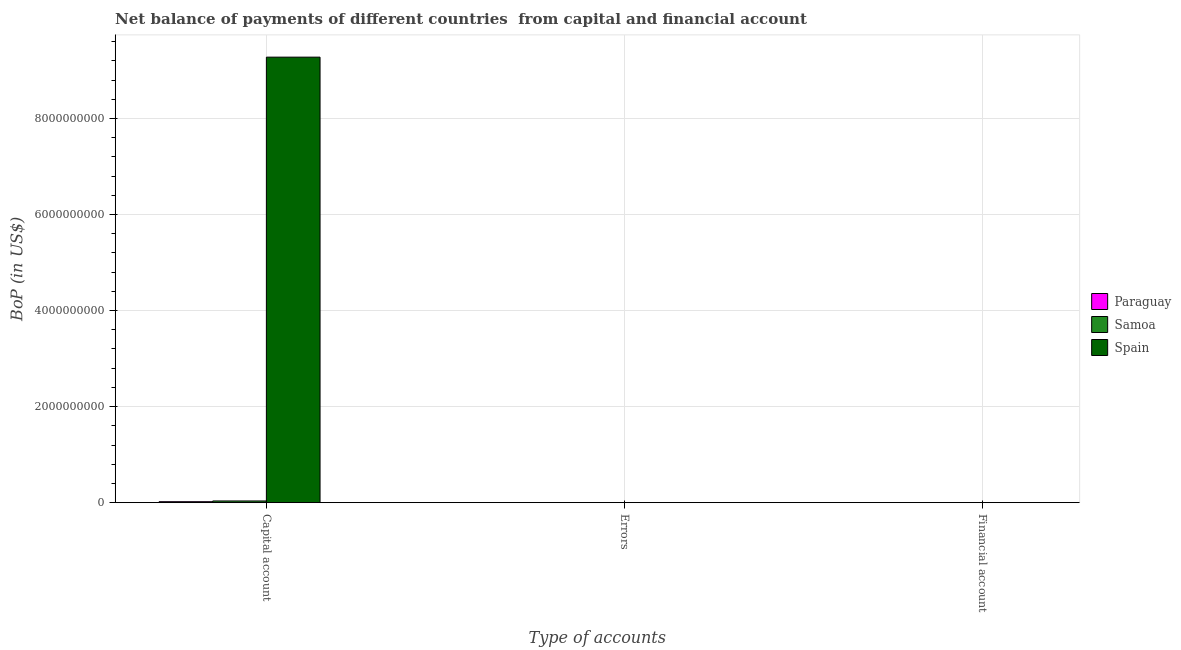Are the number of bars on each tick of the X-axis equal?
Ensure brevity in your answer.  No. What is the label of the 1st group of bars from the left?
Your answer should be compact. Capital account. What is the amount of errors in Samoa?
Provide a short and direct response. 0. Across all countries, what is the maximum amount of net capital account?
Your response must be concise. 9.28e+09. In which country was the amount of net capital account maximum?
Provide a succinct answer. Spain. What is the difference between the amount of net capital account in Samoa and that in Paraguay?
Make the answer very short. 1.51e+07. What is the ratio of the amount of net capital account in Paraguay to that in Spain?
Your answer should be compact. 0. Is the amount of net capital account in Spain less than that in Samoa?
Give a very brief answer. No. What is the difference between the highest and the second highest amount of net capital account?
Ensure brevity in your answer.  9.24e+09. What is the difference between the highest and the lowest amount of net capital account?
Provide a short and direct response. 9.26e+09. In how many countries, is the amount of net capital account greater than the average amount of net capital account taken over all countries?
Give a very brief answer. 1. Is the sum of the amount of net capital account in Spain and Samoa greater than the maximum amount of errors across all countries?
Your response must be concise. Yes. Is it the case that in every country, the sum of the amount of net capital account and amount of errors is greater than the amount of financial account?
Offer a terse response. Yes. Are all the bars in the graph horizontal?
Your response must be concise. No. Are the values on the major ticks of Y-axis written in scientific E-notation?
Give a very brief answer. No. Does the graph contain any zero values?
Give a very brief answer. Yes. Where does the legend appear in the graph?
Provide a short and direct response. Center right. How many legend labels are there?
Your answer should be very brief. 3. What is the title of the graph?
Offer a terse response. Net balance of payments of different countries  from capital and financial account. What is the label or title of the X-axis?
Your response must be concise. Type of accounts. What is the label or title of the Y-axis?
Your answer should be very brief. BoP (in US$). What is the BoP (in US$) of Paraguay in Capital account?
Your response must be concise. 2.00e+07. What is the BoP (in US$) of Samoa in Capital account?
Provide a succinct answer. 3.51e+07. What is the BoP (in US$) in Spain in Capital account?
Give a very brief answer. 9.28e+09. What is the BoP (in US$) of Samoa in Errors?
Your answer should be very brief. 0. What is the BoP (in US$) in Paraguay in Financial account?
Give a very brief answer. 0. What is the BoP (in US$) of Samoa in Financial account?
Provide a succinct answer. 0. What is the BoP (in US$) of Spain in Financial account?
Make the answer very short. 0. Across all Type of accounts, what is the maximum BoP (in US$) of Paraguay?
Your answer should be compact. 2.00e+07. Across all Type of accounts, what is the maximum BoP (in US$) of Samoa?
Keep it short and to the point. 3.51e+07. Across all Type of accounts, what is the maximum BoP (in US$) of Spain?
Make the answer very short. 9.28e+09. Across all Type of accounts, what is the minimum BoP (in US$) of Samoa?
Your response must be concise. 0. What is the total BoP (in US$) in Paraguay in the graph?
Keep it short and to the point. 2.00e+07. What is the total BoP (in US$) of Samoa in the graph?
Offer a very short reply. 3.51e+07. What is the total BoP (in US$) of Spain in the graph?
Your answer should be compact. 9.28e+09. What is the average BoP (in US$) of Paraguay per Type of accounts?
Ensure brevity in your answer.  6.67e+06. What is the average BoP (in US$) in Samoa per Type of accounts?
Provide a short and direct response. 1.17e+07. What is the average BoP (in US$) in Spain per Type of accounts?
Offer a very short reply. 3.09e+09. What is the difference between the BoP (in US$) in Paraguay and BoP (in US$) in Samoa in Capital account?
Ensure brevity in your answer.  -1.51e+07. What is the difference between the BoP (in US$) in Paraguay and BoP (in US$) in Spain in Capital account?
Offer a terse response. -9.26e+09. What is the difference between the BoP (in US$) of Samoa and BoP (in US$) of Spain in Capital account?
Offer a very short reply. -9.24e+09. What is the difference between the highest and the lowest BoP (in US$) of Paraguay?
Your response must be concise. 2.00e+07. What is the difference between the highest and the lowest BoP (in US$) in Samoa?
Provide a succinct answer. 3.51e+07. What is the difference between the highest and the lowest BoP (in US$) in Spain?
Offer a very short reply. 9.28e+09. 